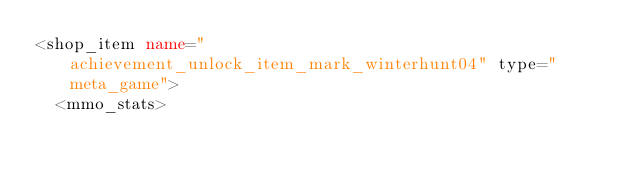<code> <loc_0><loc_0><loc_500><loc_500><_XML_><shop_item name="achievement_unlock_item_mark_winterhunt04" type="meta_game">
	<mmo_stats></code> 